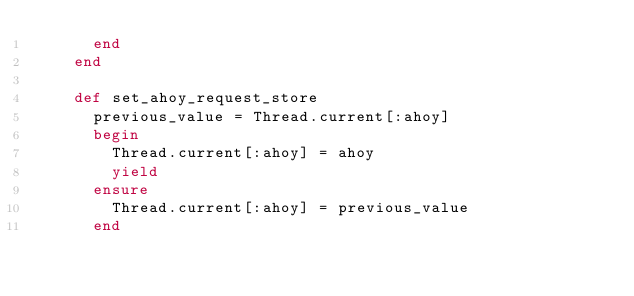Convert code to text. <code><loc_0><loc_0><loc_500><loc_500><_Ruby_>      end
    end

    def set_ahoy_request_store
      previous_value = Thread.current[:ahoy]
      begin
        Thread.current[:ahoy] = ahoy
        yield
      ensure
        Thread.current[:ahoy] = previous_value
      end</code> 